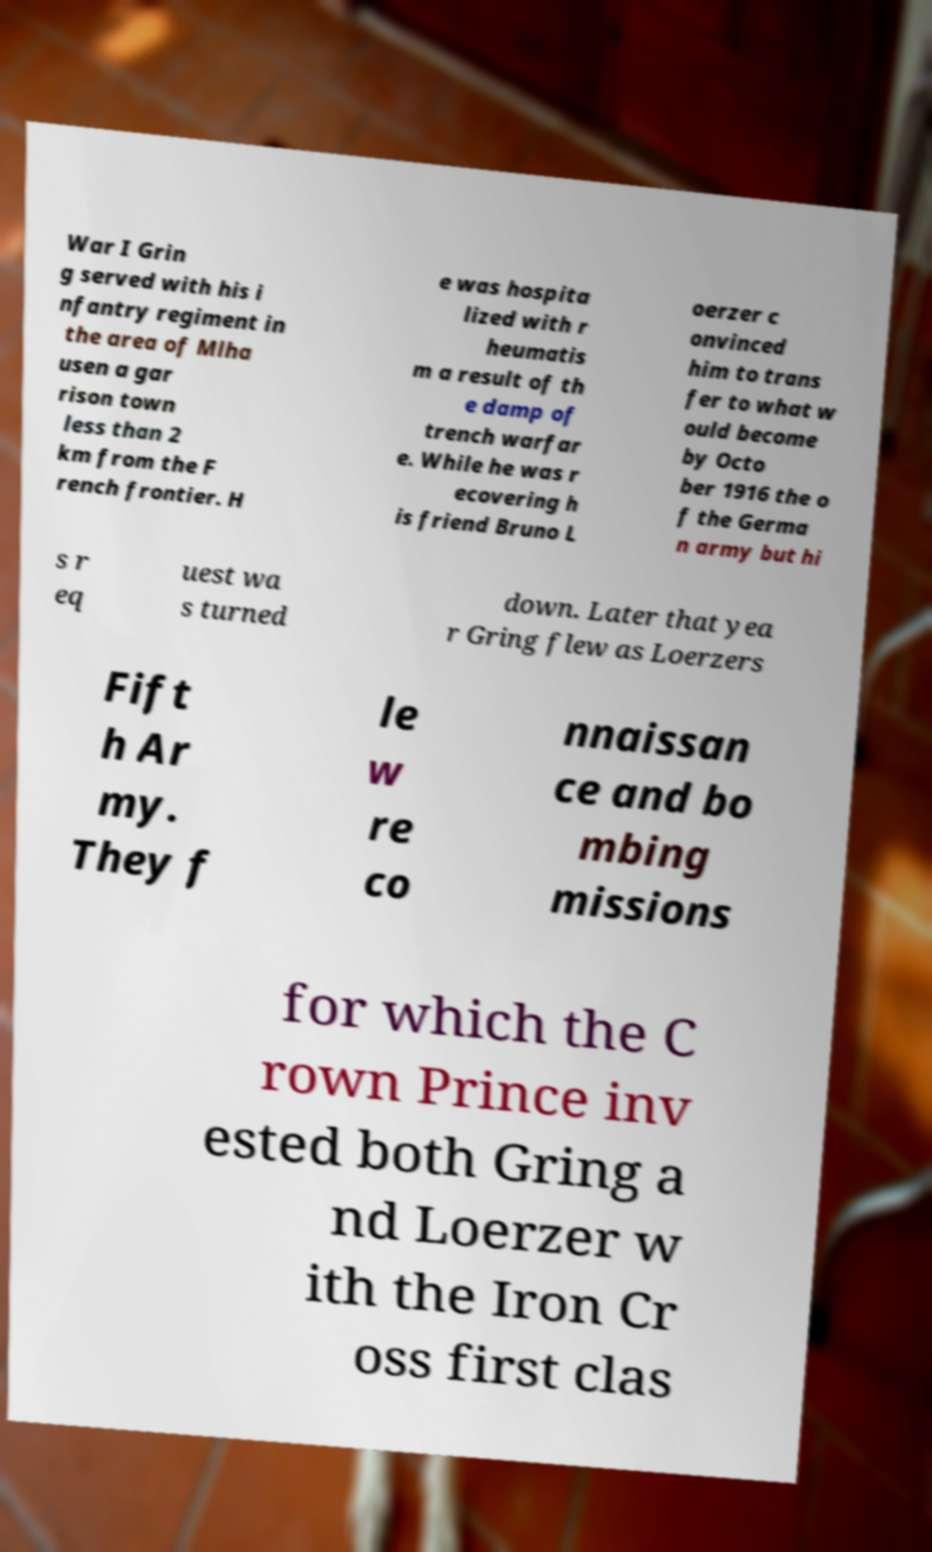Could you extract and type out the text from this image? War I Grin g served with his i nfantry regiment in the area of Mlha usen a gar rison town less than 2 km from the F rench frontier. H e was hospita lized with r heumatis m a result of th e damp of trench warfar e. While he was r ecovering h is friend Bruno L oerzer c onvinced him to trans fer to what w ould become by Octo ber 1916 the o f the Germa n army but hi s r eq uest wa s turned down. Later that yea r Gring flew as Loerzers Fift h Ar my. They f le w re co nnaissan ce and bo mbing missions for which the C rown Prince inv ested both Gring a nd Loerzer w ith the Iron Cr oss first clas 